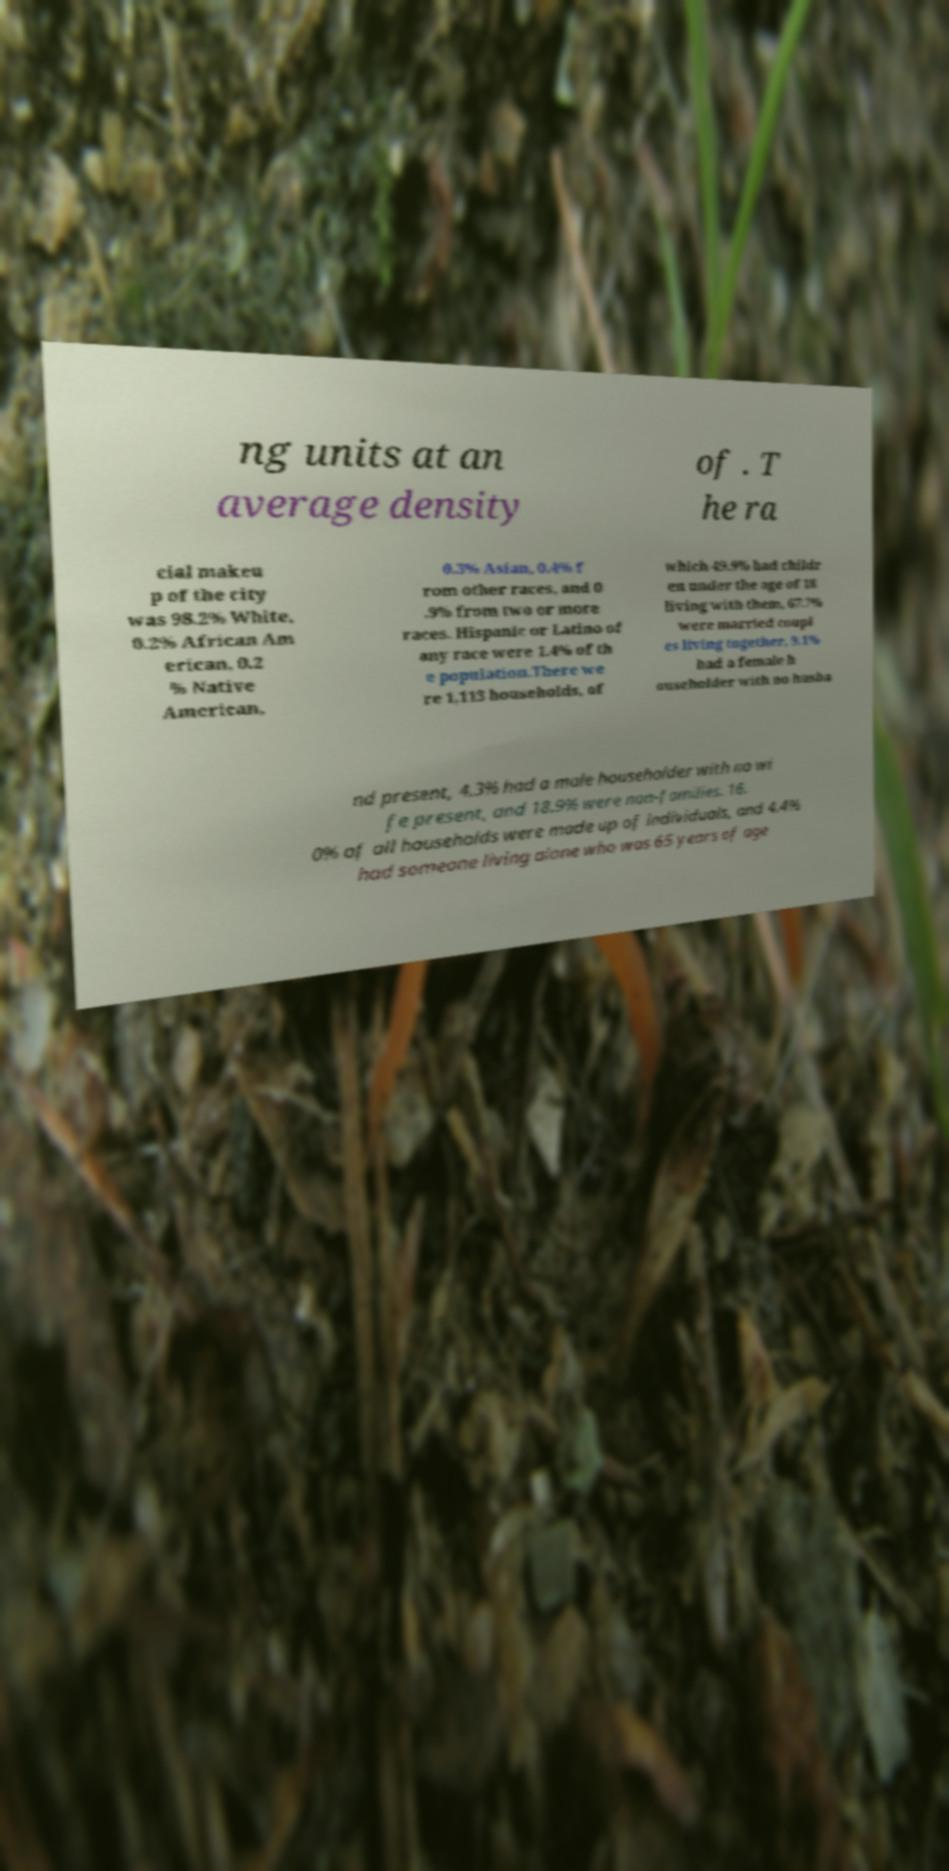I need the written content from this picture converted into text. Can you do that? ng units at an average density of . T he ra cial makeu p of the city was 98.2% White, 0.2% African Am erican, 0.2 % Native American, 0.3% Asian, 0.4% f rom other races, and 0 .9% from two or more races. Hispanic or Latino of any race were 1.4% of th e population.There we re 1,113 households, of which 49.9% had childr en under the age of 18 living with them, 67.7% were married coupl es living together, 9.1% had a female h ouseholder with no husba nd present, 4.3% had a male householder with no wi fe present, and 18.9% were non-families. 16. 0% of all households were made up of individuals, and 4.4% had someone living alone who was 65 years of age 